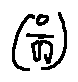Convert formula to latex. <formula><loc_0><loc_0><loc_500><loc_500>( \frac { o } { [ i ] } )</formula> 